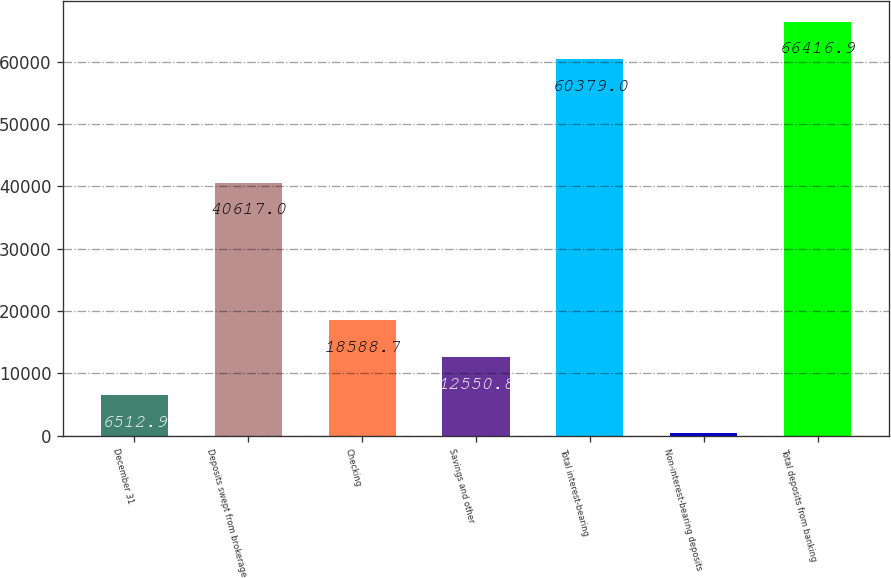<chart> <loc_0><loc_0><loc_500><loc_500><bar_chart><fcel>December 31<fcel>Deposits swept from brokerage<fcel>Checking<fcel>Savings and other<fcel>Total interest-bearing<fcel>Non-interest-bearing deposits<fcel>Total deposits from banking<nl><fcel>6512.9<fcel>40617<fcel>18588.7<fcel>12550.8<fcel>60379<fcel>475<fcel>66416.9<nl></chart> 